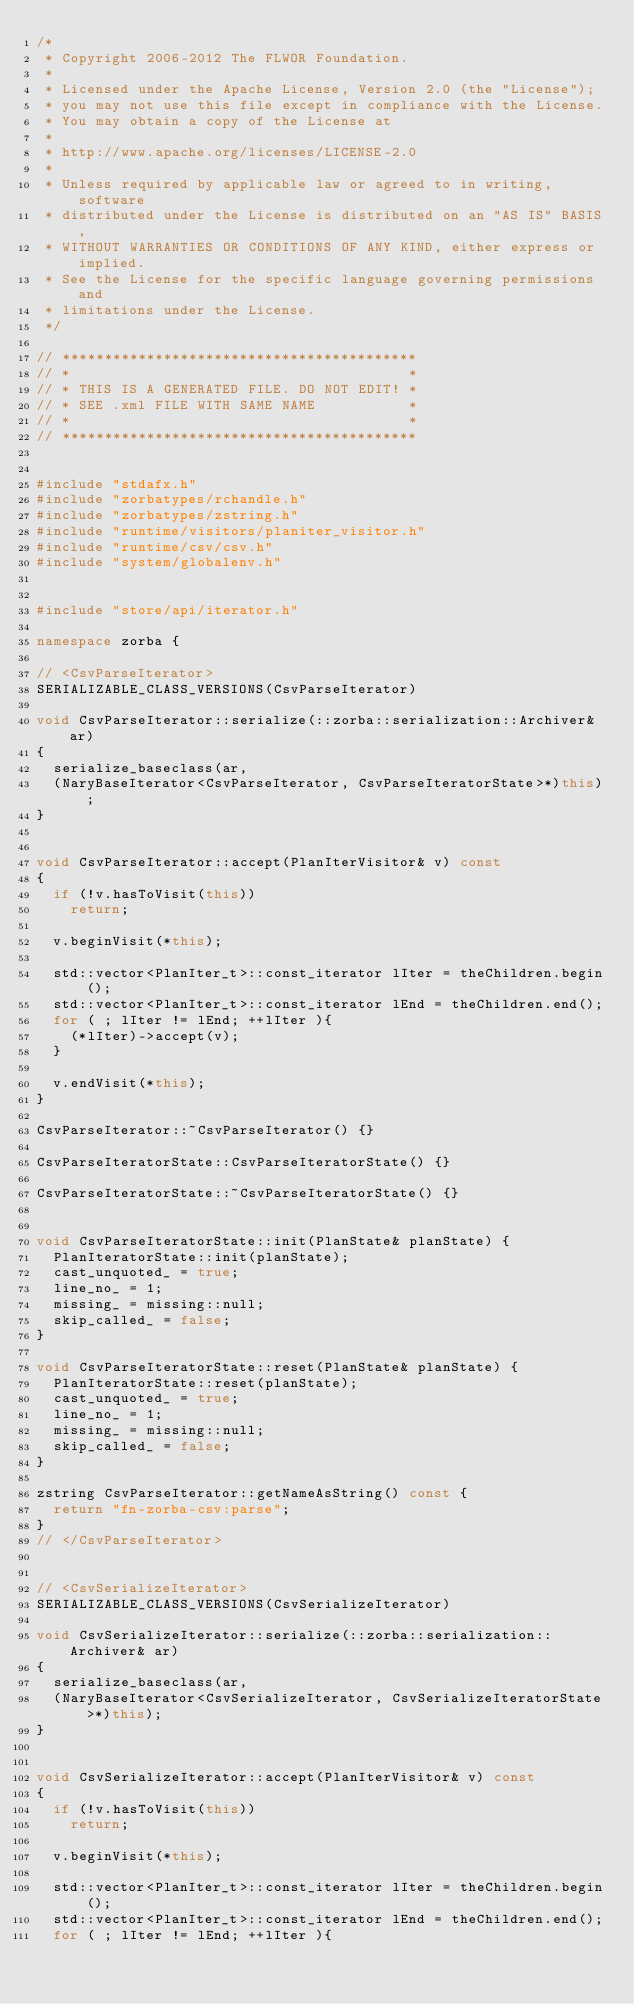Convert code to text. <code><loc_0><loc_0><loc_500><loc_500><_C++_>/*
 * Copyright 2006-2012 The FLWOR Foundation.
 *
 * Licensed under the Apache License, Version 2.0 (the "License");
 * you may not use this file except in compliance with the License.
 * You may obtain a copy of the License at
 *
 * http://www.apache.org/licenses/LICENSE-2.0
 *
 * Unless required by applicable law or agreed to in writing, software
 * distributed under the License is distributed on an "AS IS" BASIS,
 * WITHOUT WARRANTIES OR CONDITIONS OF ANY KIND, either express or implied.
 * See the License for the specific language governing permissions and
 * limitations under the License.
 */
 
// ******************************************
// *                                        *
// * THIS IS A GENERATED FILE. DO NOT EDIT! *
// * SEE .xml FILE WITH SAME NAME           *
// *                                        *
// ******************************************


#include "stdafx.h"
#include "zorbatypes/rchandle.h"
#include "zorbatypes/zstring.h"
#include "runtime/visitors/planiter_visitor.h"
#include "runtime/csv/csv.h"
#include "system/globalenv.h"


#include "store/api/iterator.h"

namespace zorba {

// <CsvParseIterator>
SERIALIZABLE_CLASS_VERSIONS(CsvParseIterator)

void CsvParseIterator::serialize(::zorba::serialization::Archiver& ar)
{
  serialize_baseclass(ar,
  (NaryBaseIterator<CsvParseIterator, CsvParseIteratorState>*)this);
}


void CsvParseIterator::accept(PlanIterVisitor& v) const
{
  if (!v.hasToVisit(this))
    return;

  v.beginVisit(*this);

  std::vector<PlanIter_t>::const_iterator lIter = theChildren.begin();
  std::vector<PlanIter_t>::const_iterator lEnd = theChildren.end();
  for ( ; lIter != lEnd; ++lIter ){
    (*lIter)->accept(v);
  }

  v.endVisit(*this);
}

CsvParseIterator::~CsvParseIterator() {}

CsvParseIteratorState::CsvParseIteratorState() {}

CsvParseIteratorState::~CsvParseIteratorState() {}


void CsvParseIteratorState::init(PlanState& planState) {
  PlanIteratorState::init(planState);
  cast_unquoted_ = true;
  line_no_ = 1;
  missing_ = missing::null;
  skip_called_ = false;
}

void CsvParseIteratorState::reset(PlanState& planState) {
  PlanIteratorState::reset(planState);
  cast_unquoted_ = true;
  line_no_ = 1;
  missing_ = missing::null;
  skip_called_ = false;
}

zstring CsvParseIterator::getNameAsString() const {
  return "fn-zorba-csv:parse";
}
// </CsvParseIterator>


// <CsvSerializeIterator>
SERIALIZABLE_CLASS_VERSIONS(CsvSerializeIterator)

void CsvSerializeIterator::serialize(::zorba::serialization::Archiver& ar)
{
  serialize_baseclass(ar,
  (NaryBaseIterator<CsvSerializeIterator, CsvSerializeIteratorState>*)this);
}


void CsvSerializeIterator::accept(PlanIterVisitor& v) const
{
  if (!v.hasToVisit(this))
    return;

  v.beginVisit(*this);

  std::vector<PlanIter_t>::const_iterator lIter = theChildren.begin();
  std::vector<PlanIter_t>::const_iterator lEnd = theChildren.end();
  for ( ; lIter != lEnd; ++lIter ){</code> 